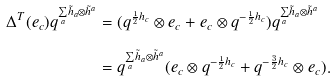Convert formula to latex. <formula><loc_0><loc_0><loc_500><loc_500>\Delta ^ { T } ( e _ { c } ) q ^ { \underset { a } { \sum } \tilde { h } _ { a } \otimes \tilde { h } ^ { a } } & = ( q ^ { \frac { 1 } { 2 } h _ { c } } \otimes e _ { c } + e _ { c } \otimes q ^ { - \frac { 1 } { 2 } h _ { c } } ) q ^ { \underset { a } { \sum } \tilde { h } _ { a } \otimes \tilde { h } ^ { a } } \\ & = q ^ { \underset { a } { \sum } \tilde { h } _ { a } \otimes \tilde { h } ^ { a } } ( e _ { c } \otimes q ^ { - \frac { 1 } { 2 } h _ { c } } + q ^ { - \frac { 3 } { 2 } h _ { c } } \otimes e _ { c } ) .</formula> 